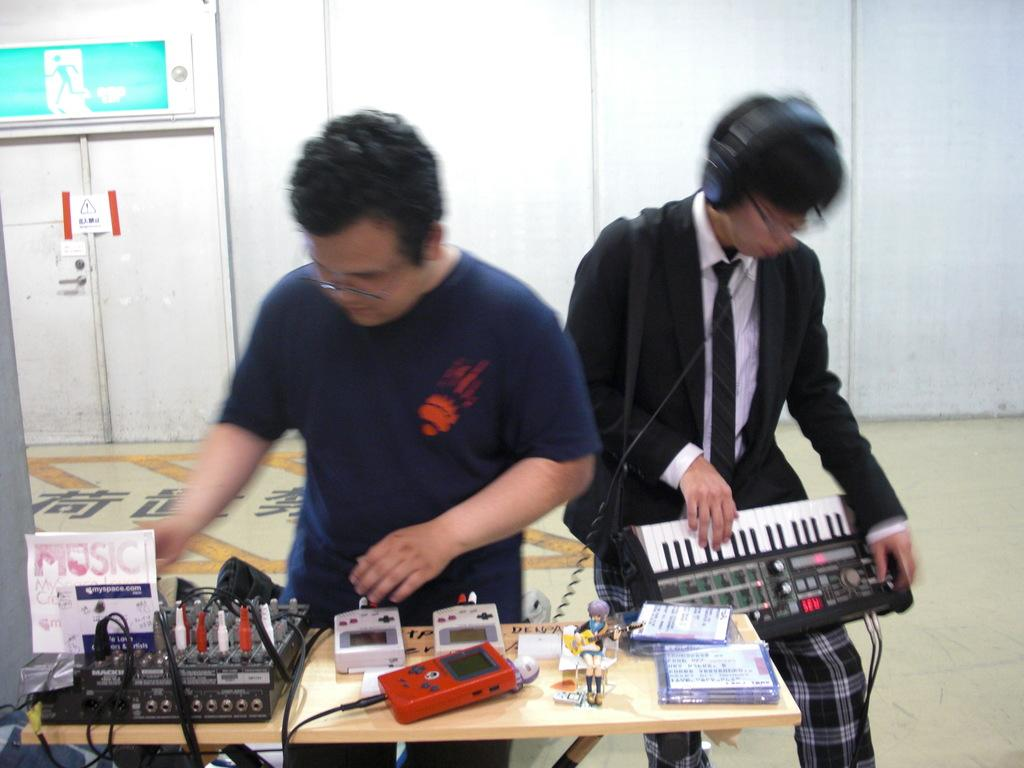How many people are in the image? There are two people standing in the image. What are the two people doing? The two people are playing musical instruments. Can you describe the third person in the image? There is a man checking the switches of a circuit in the image. What type of knee injury is the man with the locket suffering from in the image? There is no man with a locket present in the image, and no one is shown to be suffering from a knee injury. 